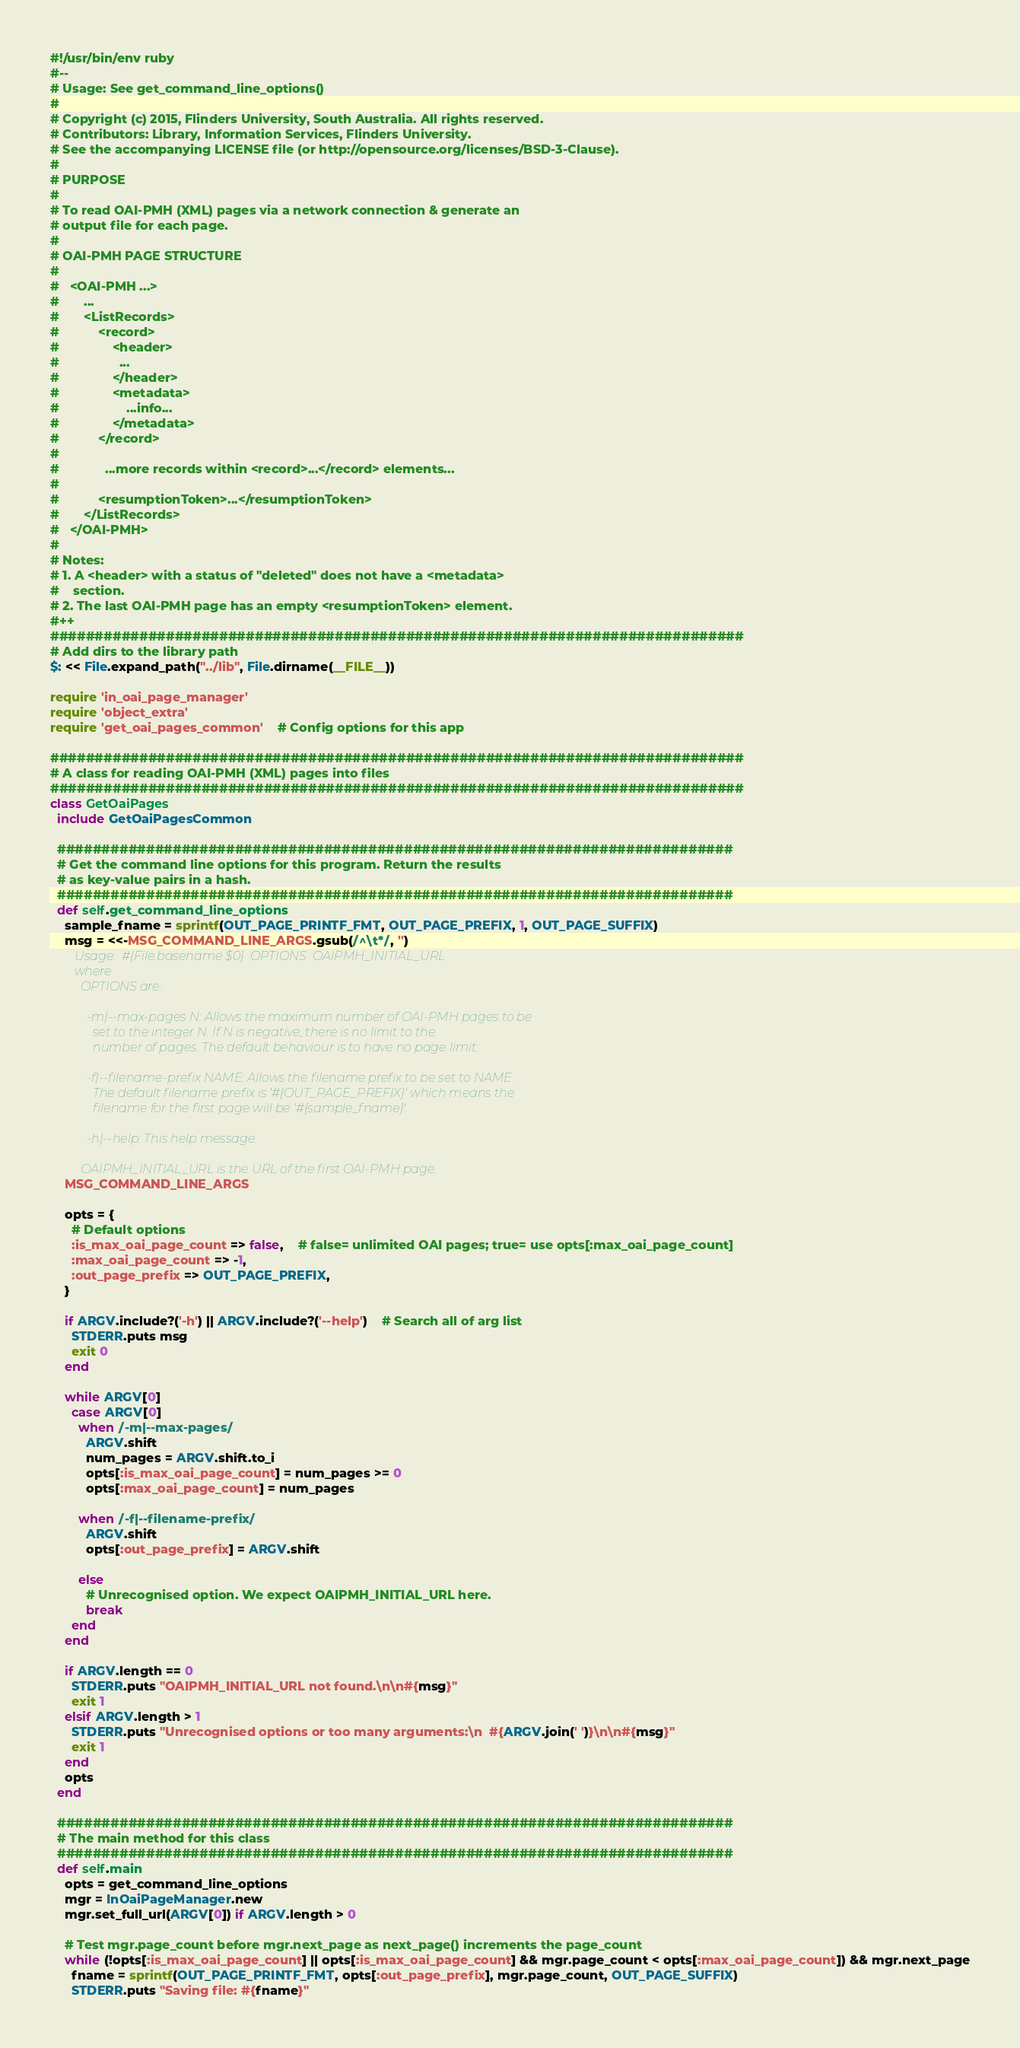Convert code to text. <code><loc_0><loc_0><loc_500><loc_500><_Ruby_>#!/usr/bin/env ruby
#--
# Usage: See get_command_line_options()
#
# Copyright (c) 2015, Flinders University, South Australia. All rights reserved.
# Contributors: Library, Information Services, Flinders University.
# See the accompanying LICENSE file (or http://opensource.org/licenses/BSD-3-Clause).
# 
# PURPOSE
#
# To read OAI-PMH (XML) pages via a network connection & generate an
# output file for each page.
#
# OAI-PMH PAGE STRUCTURE
#
#   <OAI-PMH ...>
#       ...
#       <ListRecords>
#           <record>
#               <header>
#                 ...
#               </header>
#               <metadata>
#                   ...info...
#               </metadata>
#           </record>
#		
#             ...more records within <record>...</record> elements...
#		
#           <resumptionToken>...</resumptionToken>
#       </ListRecords>
#   </OAI-PMH>
#
# Notes:
# 1. A <header> with a status of "deleted" does not have a <metadata>
#    section.
# 2. The last OAI-PMH page has an empty <resumptionToken> element.
#++
##############################################################################
# Add dirs to the library path
$: << File.expand_path("../lib", File.dirname(__FILE__))

require 'in_oai_page_manager'
require 'object_extra'
require 'get_oai_pages_common'	# Config options for this app

##############################################################################
# A class for reading OAI-PMH (XML) pages into files
##############################################################################
class GetOaiPages
  include GetOaiPagesCommon

  ############################################################################
  # Get the command line options for this program. Return the results
  # as key-value pairs in a hash.
  ############################################################################
  def self.get_command_line_options
    sample_fname = sprintf(OUT_PAGE_PRINTF_FMT, OUT_PAGE_PREFIX, 1, OUT_PAGE_SUFFIX)
    msg = <<-MSG_COMMAND_LINE_ARGS.gsub(/^\t*/, '')
		Usage:  #{File.basename $0}  OPTIONS  OAIPMH_INITIAL_URL
		where
		  OPTIONS are:

		    -m|--max-pages N: Allows the maximum number of OAI-PMH pages to be
		      set to the integer N. If N is negative, there is no limit to the
		      number of pages. The default behaviour is to have no page limit.

		    -f|--filename-prefix NAME: Allows the filename prefix to be set to NAME.
		      The default filename prefix is '#{OUT_PAGE_PREFIX}' which means the
		      filename for the first page will be '#{sample_fname}'.

		    -h|--help: This help message.

		  OAIPMH_INITIAL_URL is the URL of the first OAI-PMH page.
    MSG_COMMAND_LINE_ARGS

    opts = {
      # Default options
      :is_max_oai_page_count => false,	# false= unlimited OAI pages; true= use opts[:max_oai_page_count]
      :max_oai_page_count => -1,
      :out_page_prefix => OUT_PAGE_PREFIX,
    }

    if ARGV.include?('-h') || ARGV.include?('--help')	# Search all of arg list
      STDERR.puts msg
      exit 0
    end

    while ARGV[0]
      case ARGV[0]
        when /-m|--max-pages/
          ARGV.shift
          num_pages = ARGV.shift.to_i
          opts[:is_max_oai_page_count] = num_pages >= 0
          opts[:max_oai_page_count] = num_pages

        when /-f|--filename-prefix/
          ARGV.shift
          opts[:out_page_prefix] = ARGV.shift

        else
          # Unrecognised option. We expect OAIPMH_INITIAL_URL here.
          break
      end
    end

    if ARGV.length == 0
      STDERR.puts "OAIPMH_INITIAL_URL not found.\n\n#{msg}"
      exit 1
    elsif ARGV.length > 1
      STDERR.puts "Unrecognised options or too many arguments:\n  #{ARGV.join(' ')}\n\n#{msg}"
      exit 1
    end
    opts
  end

  ############################################################################
  # The main method for this class
  ############################################################################
  def self.main
    opts = get_command_line_options
    mgr = InOaiPageManager.new
    mgr.set_full_url(ARGV[0]) if ARGV.length > 0

    # Test mgr.page_count before mgr.next_page as next_page() increments the page_count
    while (!opts[:is_max_oai_page_count] || opts[:is_max_oai_page_count] && mgr.page_count < opts[:max_oai_page_count]) && mgr.next_page
      fname = sprintf(OUT_PAGE_PRINTF_FMT, opts[:out_page_prefix], mgr.page_count, OUT_PAGE_SUFFIX)
      STDERR.puts "Saving file: #{fname}"</code> 